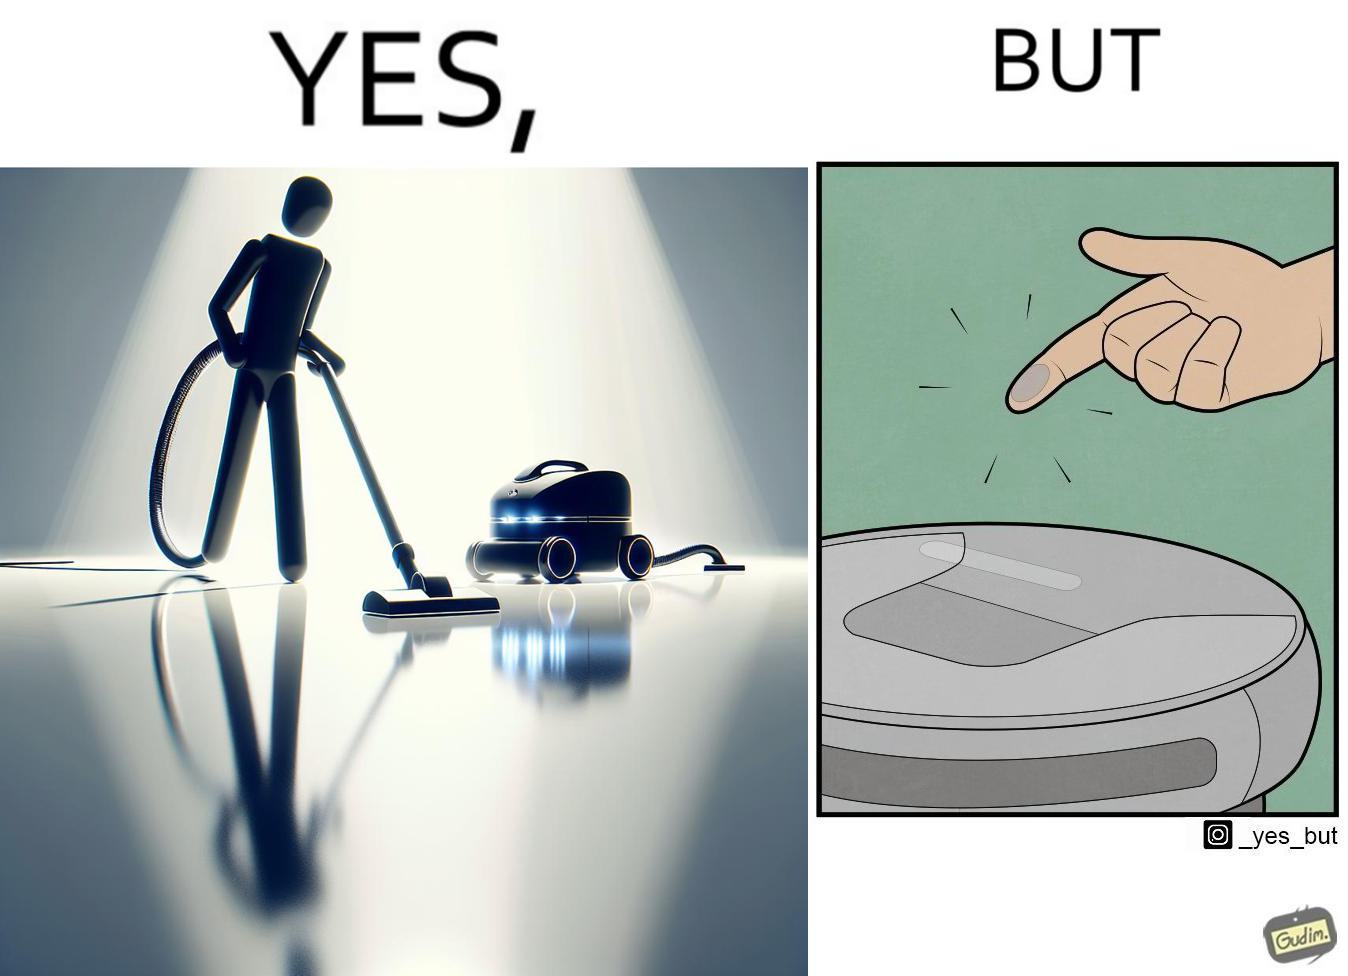Is there satirical content in this image? Yes, this image is satirical. 